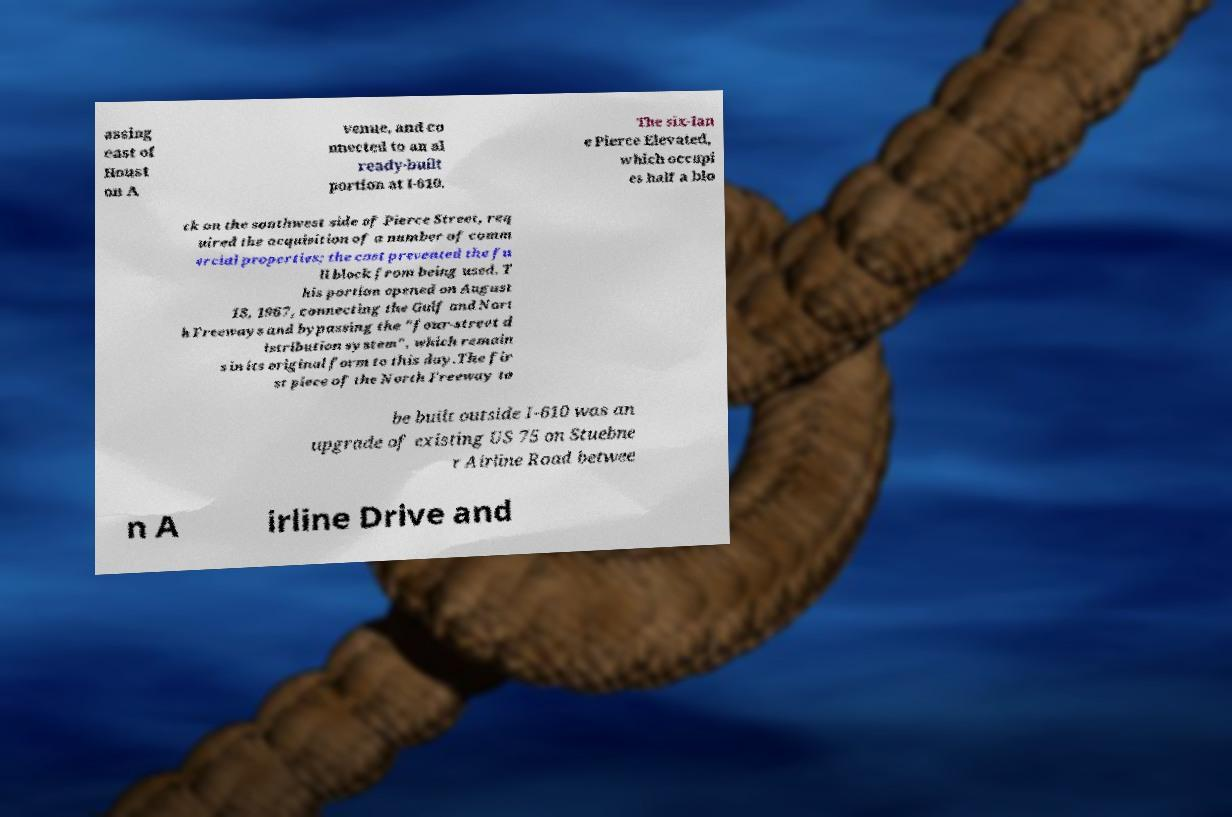What messages or text are displayed in this image? I need them in a readable, typed format. assing east of Houst on A venue, and co nnected to an al ready-built portion at I-610. The six-lan e Pierce Elevated, which occupi es half a blo ck on the southwest side of Pierce Street, req uired the acquisition of a number of comm ercial properties; the cost prevented the fu ll block from being used. T his portion opened on August 18, 1967, connecting the Gulf and Nort h Freeways and bypassing the "four-street d istribution system", which remain s in its original form to this day.The fir st piece of the North Freeway to be built outside I-610 was an upgrade of existing US 75 on Stuebne r Airline Road betwee n A irline Drive and 